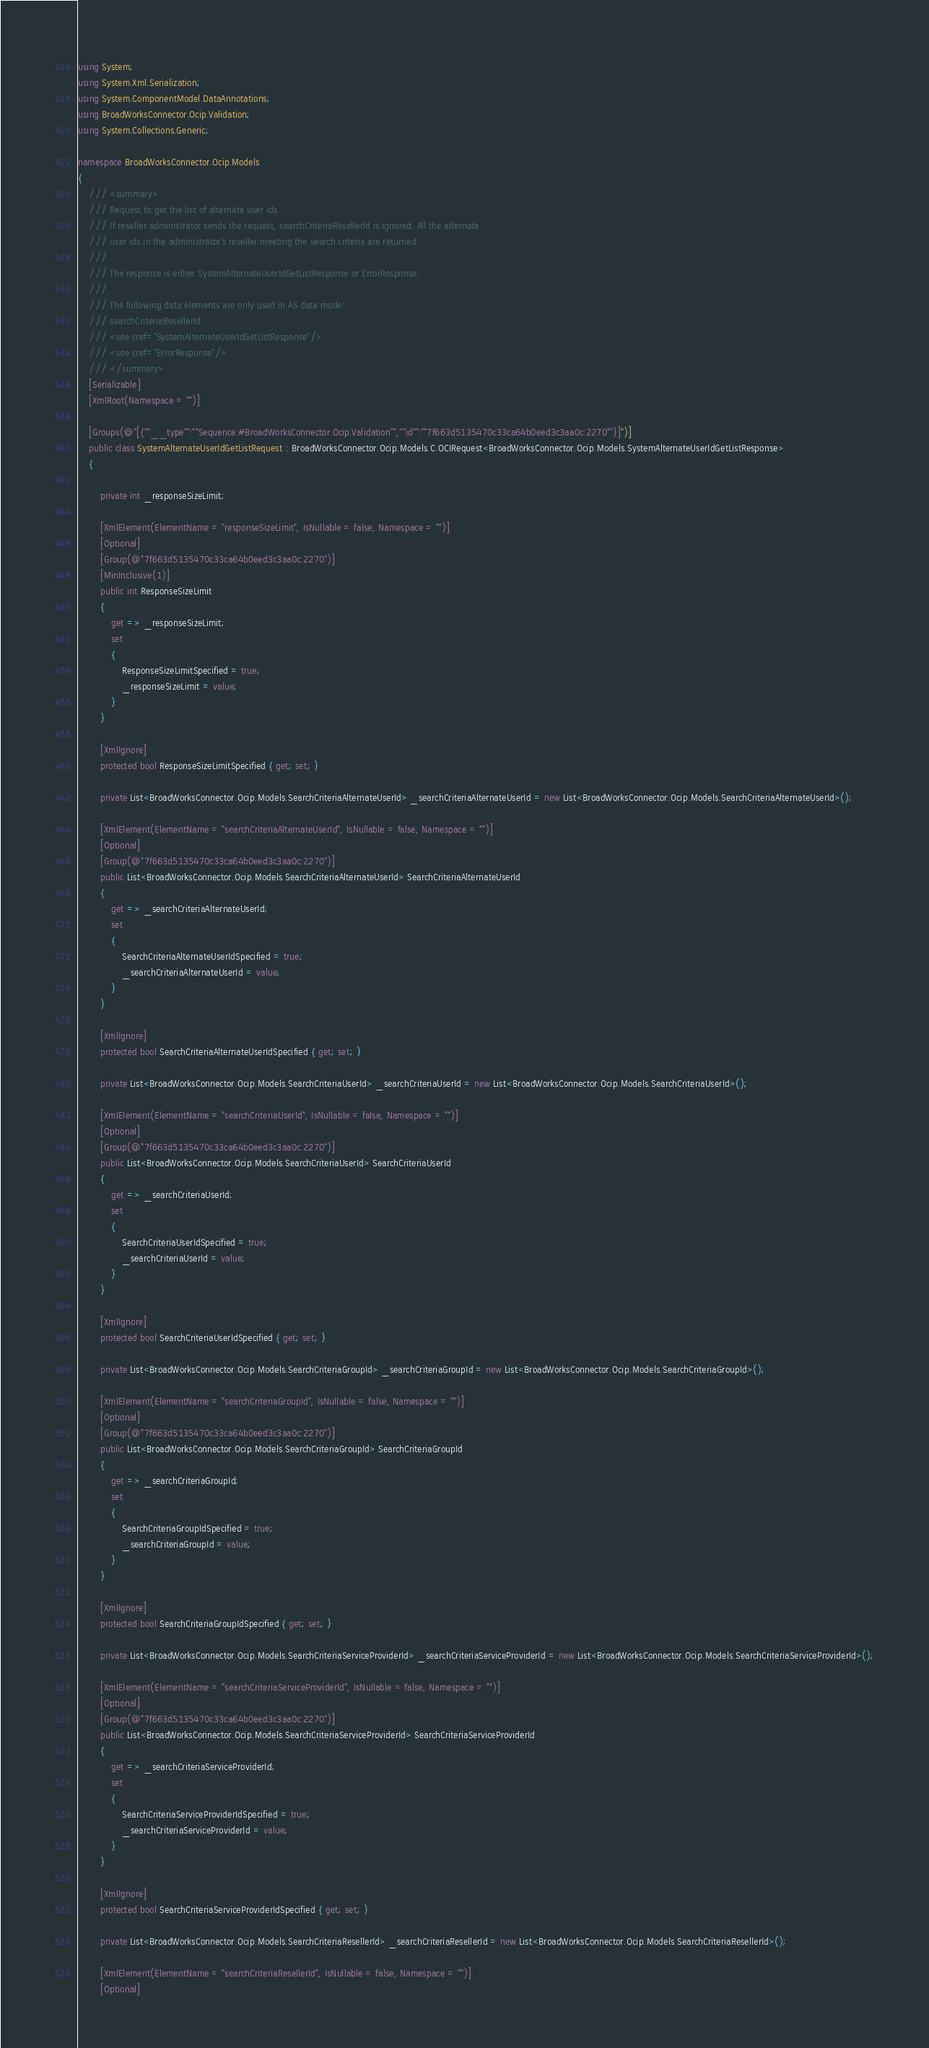<code> <loc_0><loc_0><loc_500><loc_500><_C#_>using System;
using System.Xml.Serialization;
using System.ComponentModel.DataAnnotations;
using BroadWorksConnector.Ocip.Validation;
using System.Collections.Generic;

namespace BroadWorksConnector.Ocip.Models
{
    /// <summary>
    /// Request to get the list of alternate user ids.
    /// If reseller administrator sends the request, searchCriteriaResellerId is ignored. All the alternate
    /// user ids in the administrator's reseller meeting the search criteria are returned.
    /// 
    /// The response is either SystemAlternateUserIdGetListResponse or ErrorResponse.
    /// 
    /// The following data elements are only used in AS data mode:
    /// searchCriteriaResellerId
    /// <see cref="SystemAlternateUserIdGetListResponse"/>
    /// <see cref="ErrorResponse"/>
    /// </summary>
    [Serializable]
    [XmlRoot(Namespace = "")]

    [Groups(@"[{""__type"":""Sequence:#BroadWorksConnector.Ocip.Validation"",""id"":""7f663d5135470c33ca64b0eed3c3aa0c:2270""}]")]
    public class SystemAlternateUserIdGetListRequest : BroadWorksConnector.Ocip.Models.C.OCIRequest<BroadWorksConnector.Ocip.Models.SystemAlternateUserIdGetListResponse>
    {

        private int _responseSizeLimit;

        [XmlElement(ElementName = "responseSizeLimit", IsNullable = false, Namespace = "")]
        [Optional]
        [Group(@"7f663d5135470c33ca64b0eed3c3aa0c:2270")]
        [MinInclusive(1)]
        public int ResponseSizeLimit
        {
            get => _responseSizeLimit;
            set
            {
                ResponseSizeLimitSpecified = true;
                _responseSizeLimit = value;
            }
        }

        [XmlIgnore]
        protected bool ResponseSizeLimitSpecified { get; set; }

        private List<BroadWorksConnector.Ocip.Models.SearchCriteriaAlternateUserId> _searchCriteriaAlternateUserId = new List<BroadWorksConnector.Ocip.Models.SearchCriteriaAlternateUserId>();

        [XmlElement(ElementName = "searchCriteriaAlternateUserId", IsNullable = false, Namespace = "")]
        [Optional]
        [Group(@"7f663d5135470c33ca64b0eed3c3aa0c:2270")]
        public List<BroadWorksConnector.Ocip.Models.SearchCriteriaAlternateUserId> SearchCriteriaAlternateUserId
        {
            get => _searchCriteriaAlternateUserId;
            set
            {
                SearchCriteriaAlternateUserIdSpecified = true;
                _searchCriteriaAlternateUserId = value;
            }
        }

        [XmlIgnore]
        protected bool SearchCriteriaAlternateUserIdSpecified { get; set; }

        private List<BroadWorksConnector.Ocip.Models.SearchCriteriaUserId> _searchCriteriaUserId = new List<BroadWorksConnector.Ocip.Models.SearchCriteriaUserId>();

        [XmlElement(ElementName = "searchCriteriaUserId", IsNullable = false, Namespace = "")]
        [Optional]
        [Group(@"7f663d5135470c33ca64b0eed3c3aa0c:2270")]
        public List<BroadWorksConnector.Ocip.Models.SearchCriteriaUserId> SearchCriteriaUserId
        {
            get => _searchCriteriaUserId;
            set
            {
                SearchCriteriaUserIdSpecified = true;
                _searchCriteriaUserId = value;
            }
        }

        [XmlIgnore]
        protected bool SearchCriteriaUserIdSpecified { get; set; }

        private List<BroadWorksConnector.Ocip.Models.SearchCriteriaGroupId> _searchCriteriaGroupId = new List<BroadWorksConnector.Ocip.Models.SearchCriteriaGroupId>();

        [XmlElement(ElementName = "searchCriteriaGroupId", IsNullable = false, Namespace = "")]
        [Optional]
        [Group(@"7f663d5135470c33ca64b0eed3c3aa0c:2270")]
        public List<BroadWorksConnector.Ocip.Models.SearchCriteriaGroupId> SearchCriteriaGroupId
        {
            get => _searchCriteriaGroupId;
            set
            {
                SearchCriteriaGroupIdSpecified = true;
                _searchCriteriaGroupId = value;
            }
        }

        [XmlIgnore]
        protected bool SearchCriteriaGroupIdSpecified { get; set; }

        private List<BroadWorksConnector.Ocip.Models.SearchCriteriaServiceProviderId> _searchCriteriaServiceProviderId = new List<BroadWorksConnector.Ocip.Models.SearchCriteriaServiceProviderId>();

        [XmlElement(ElementName = "searchCriteriaServiceProviderId", IsNullable = false, Namespace = "")]
        [Optional]
        [Group(@"7f663d5135470c33ca64b0eed3c3aa0c:2270")]
        public List<BroadWorksConnector.Ocip.Models.SearchCriteriaServiceProviderId> SearchCriteriaServiceProviderId
        {
            get => _searchCriteriaServiceProviderId;
            set
            {
                SearchCriteriaServiceProviderIdSpecified = true;
                _searchCriteriaServiceProviderId = value;
            }
        }

        [XmlIgnore]
        protected bool SearchCriteriaServiceProviderIdSpecified { get; set; }

        private List<BroadWorksConnector.Ocip.Models.SearchCriteriaResellerId> _searchCriteriaResellerId = new List<BroadWorksConnector.Ocip.Models.SearchCriteriaResellerId>();

        [XmlElement(ElementName = "searchCriteriaResellerId", IsNullable = false, Namespace = "")]
        [Optional]</code> 